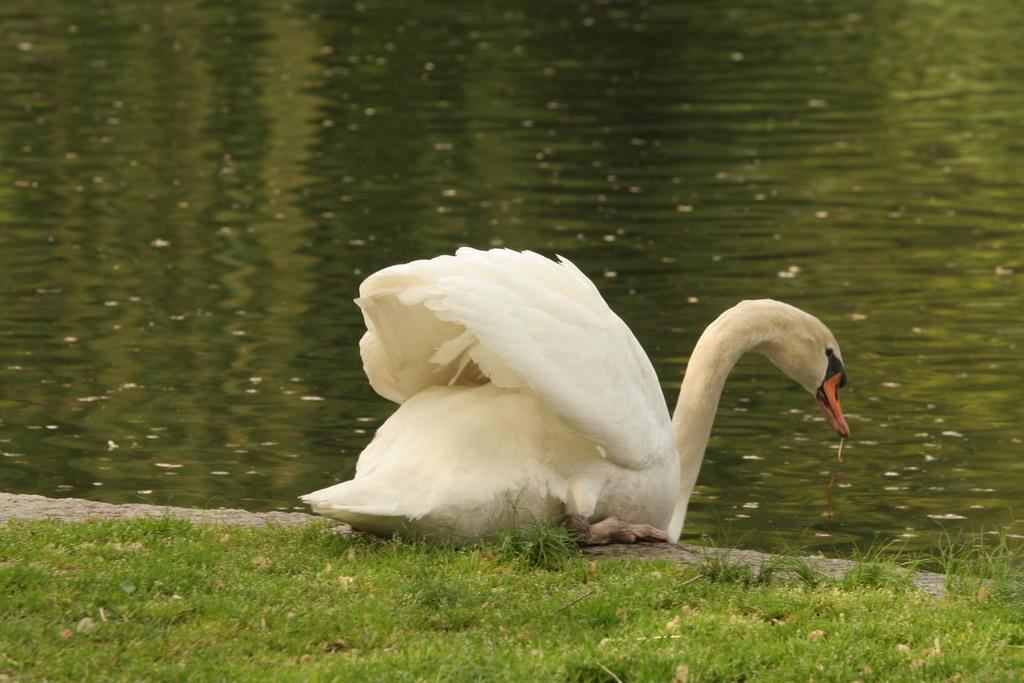What animal is present in the image? There is a swan in the image. What type of terrain is visible at the bottom of the image? There is grass at the bottom of the image. What can be seen in the background of the image? There is water visible in the background of the image. What type of business is being conducted in the image? There is no indication of any business activity in the image; it features a swan in a grassy area with water in the background. 